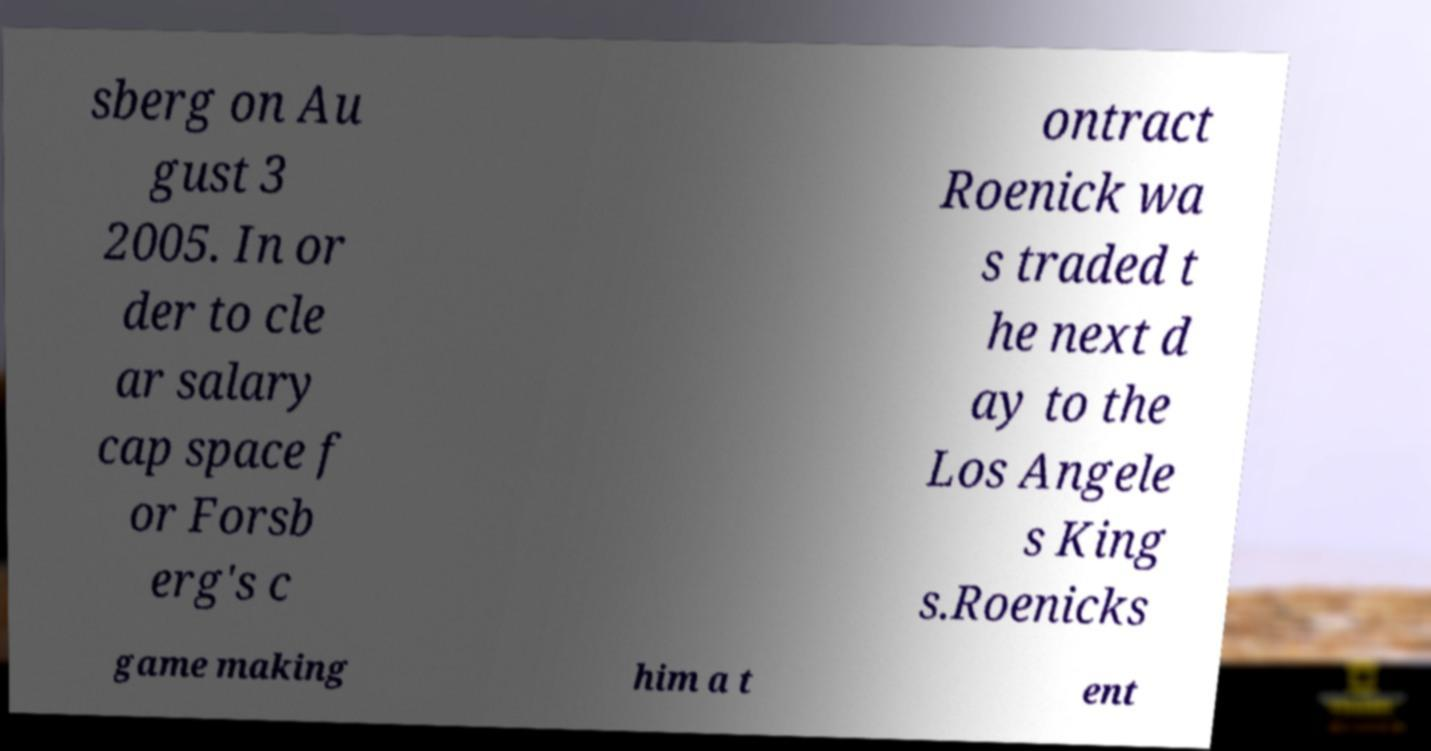Can you read and provide the text displayed in the image?This photo seems to have some interesting text. Can you extract and type it out for me? sberg on Au gust 3 2005. In or der to cle ar salary cap space f or Forsb erg's c ontract Roenick wa s traded t he next d ay to the Los Angele s King s.Roenicks game making him a t ent 